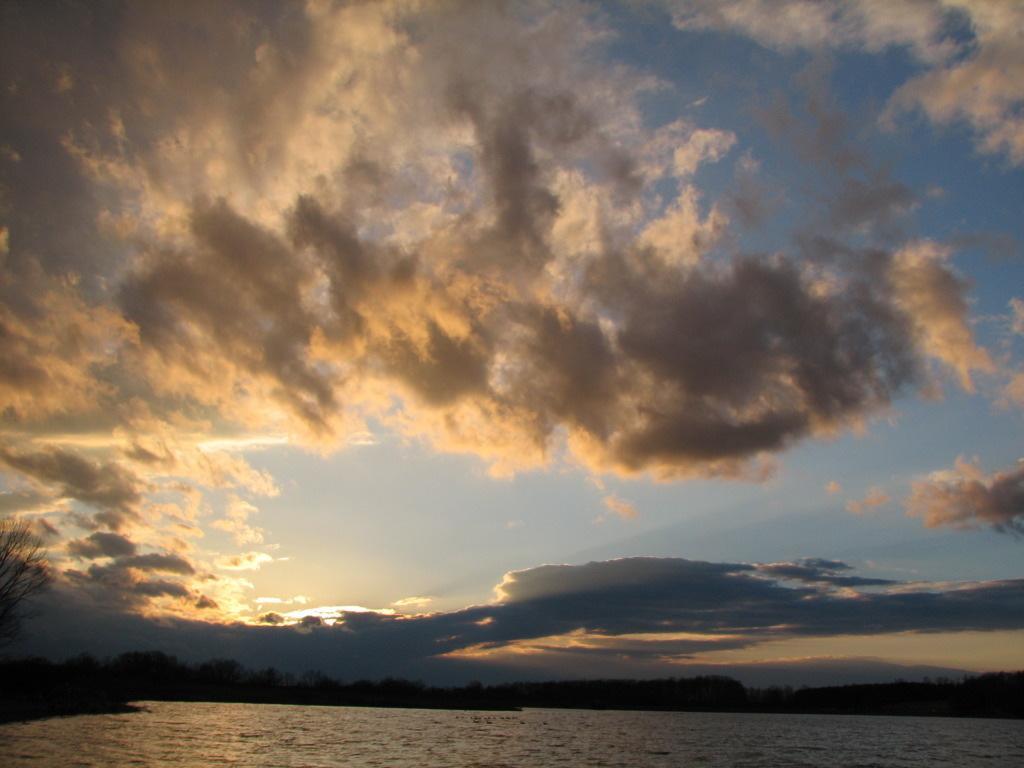Describe this image in one or two sentences. In this image, we can see trees. At the top, there are clouds in the sky and at the bottom, there is water. 